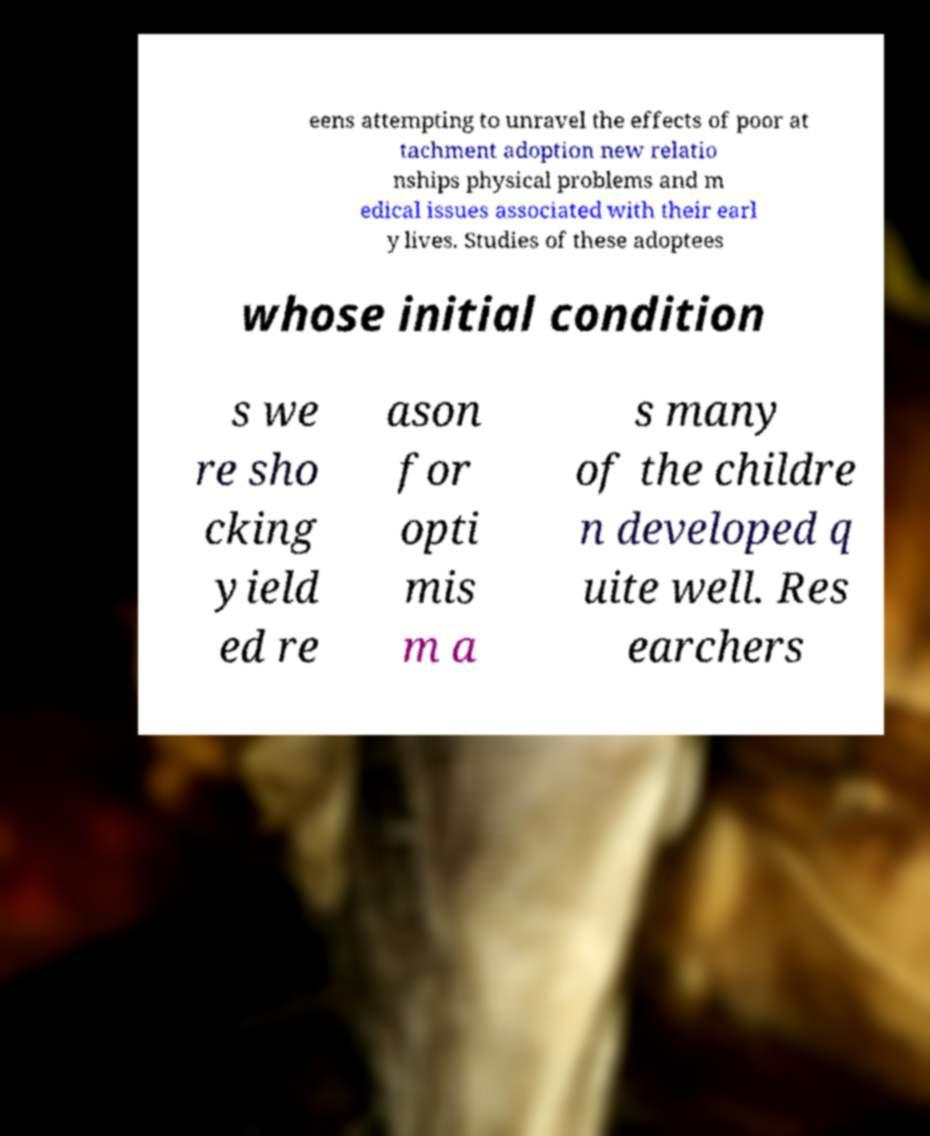Could you extract and type out the text from this image? eens attempting to unravel the effects of poor at tachment adoption new relatio nships physical problems and m edical issues associated with their earl y lives. Studies of these adoptees whose initial condition s we re sho cking yield ed re ason for opti mis m a s many of the childre n developed q uite well. Res earchers 